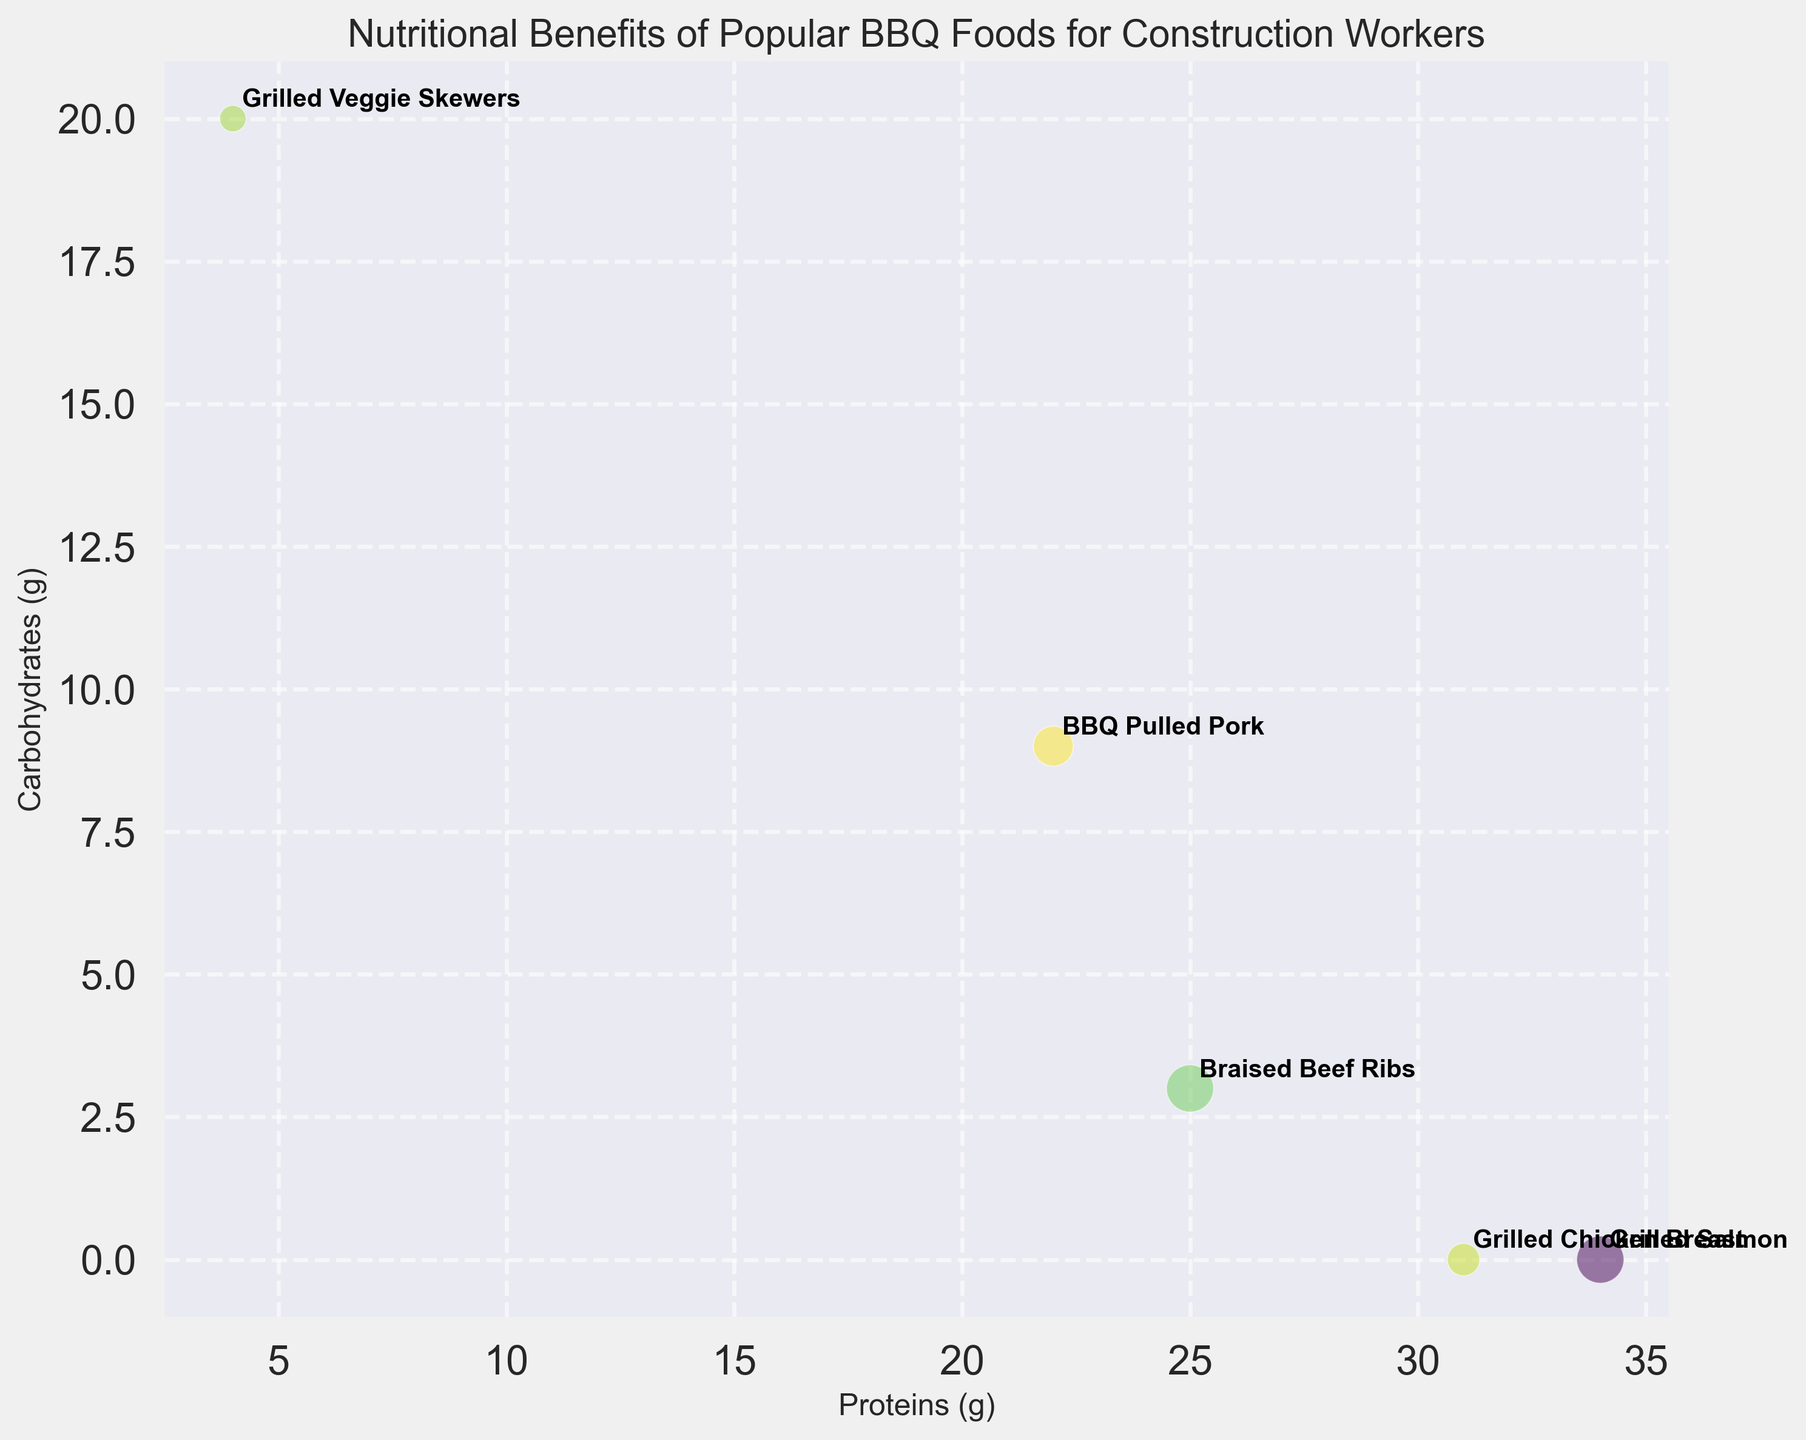What food has the highest amount of protein among the options plotted? Look at the x-axis which represents protein content. The food furthest to the right will have the highest protein content.
Answer: Grilled Salmon Which food has the fewest carbohydrates among the options plotted? Look at the y-axis which represents carbohydrate content. The food closest to the bottom will have the fewest carbohydrates.
Answer: Grilled Chicken Breast What food has the largest bubble in the chart? The size of the bubble represents the calorie content. The largest bubble will be the food with the highest calorie content.
Answer: Braised Beef Ribs Which food is both high in protein and low in carbohydrates? Find the food that is both far to the right on the x-axis (high protein) and low on the y-axis (low carbohydrates).
Answer: Grilled Salmon Which food has more calories, Grilled Chicken Breast or BBQ Pulled Pork? Compare the sizes of the bubbles for Grilled Chicken Breast and BBQ Pulled Pork. The larger bubble will have more calories.
Answer: BBQ Pulled Pork How many foods have over 20g of carbohydrates? Identify foods that are plotted above the 20g mark on the y-axis and count them.
Answer: 1 (Grilled Veggie Skewers) What is the difference in protein content between Braised Beef Ribs and BBQ Pulled Pork? Look at the x-axis values for both foods and subtract the smaller value from the larger one.
Answer: 3 grams Which has fewer carbohydrates, Grilled Veggie Skewers or Grilled Chicken Breast? Compare the y-axis positions (carbohydrates) of Grilled Veggie Skewers and Grilled Chicken Breast. The one closer to the bottom has fewer carbohydrates.
Answer: Grilled Chicken Breast What food has the second highest calorie content? Identify the two largest bubbles in the chart and determine which is the second largest.
Answer: Grilled Salmon Which food combines moderate protein and moderate carbohydrates content? Find the food that is in the middle range of both axes (neither too high nor too low).
Answer: BBQ Pulled Pork 